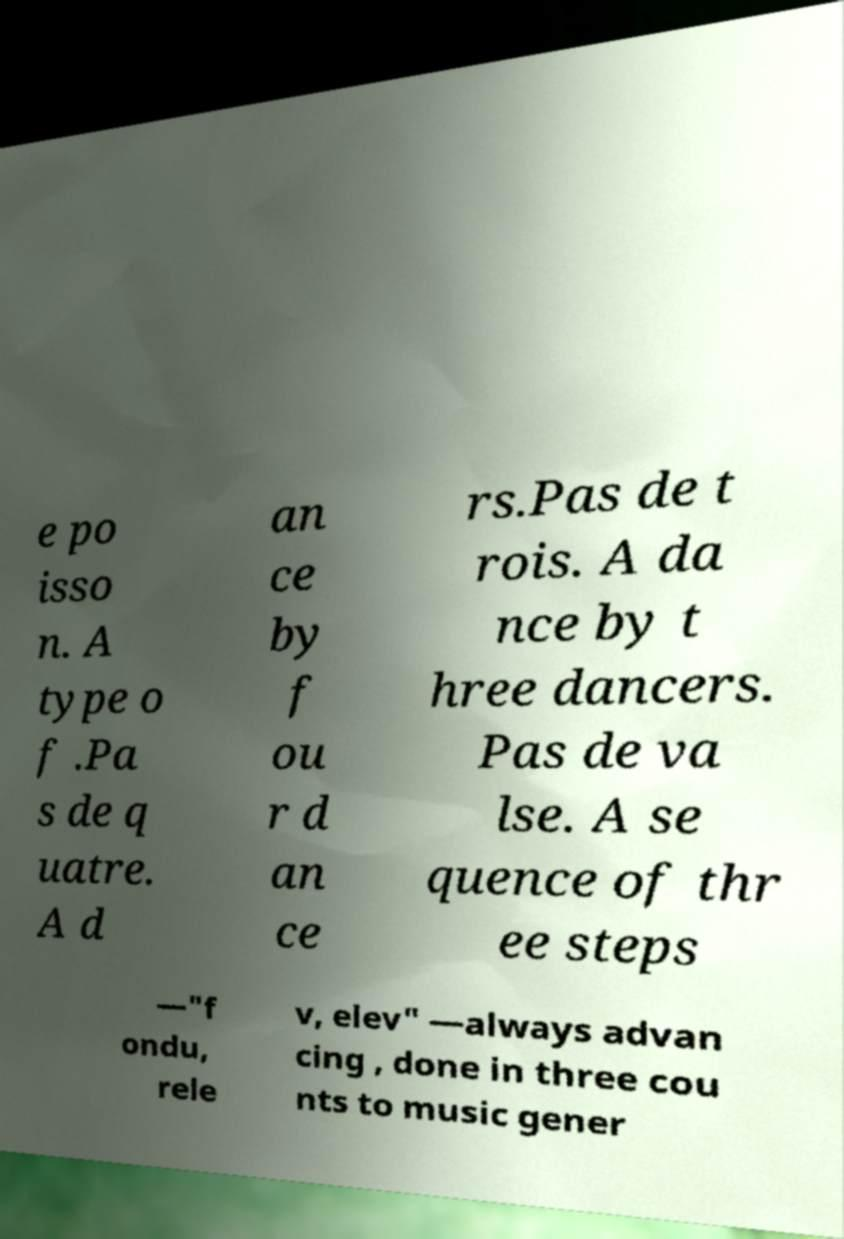Could you assist in decoding the text presented in this image and type it out clearly? e po isso n. A type o f .Pa s de q uatre. A d an ce by f ou r d an ce rs.Pas de t rois. A da nce by t hree dancers. Pas de va lse. A se quence of thr ee steps —"f ondu, rele v, elev" —always advan cing , done in three cou nts to music gener 